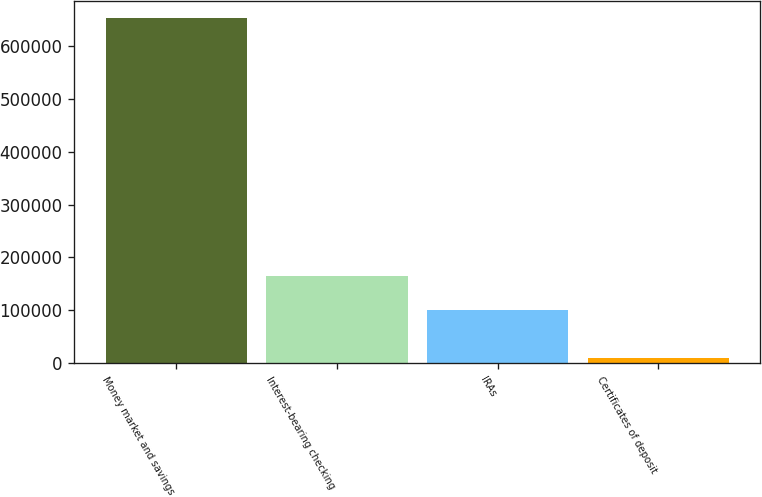Convert chart. <chart><loc_0><loc_0><loc_500><loc_500><bar_chart><fcel>Money market and savings<fcel>Interest-bearing checking<fcel>IRAs<fcel>Certificates of deposit<nl><fcel>653126<fcel>165468<fcel>101085<fcel>9297<nl></chart> 